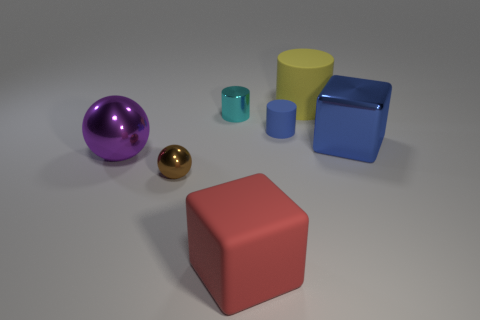Add 2 large red objects. How many objects exist? 9 Subtract all cylinders. How many objects are left? 4 Subtract all big things. Subtract all metallic spheres. How many objects are left? 1 Add 5 large blue blocks. How many large blue blocks are left? 6 Add 6 small purple metal cylinders. How many small purple metal cylinders exist? 6 Subtract 1 blue cylinders. How many objects are left? 6 